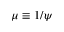<formula> <loc_0><loc_0><loc_500><loc_500>\mu \equiv 1 / \psi</formula> 